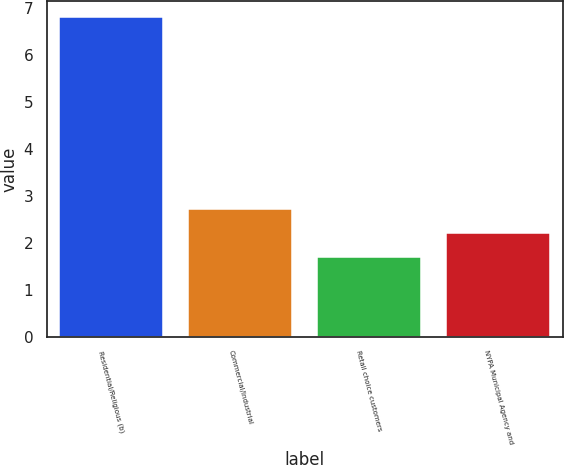Convert chart. <chart><loc_0><loc_0><loc_500><loc_500><bar_chart><fcel>Residential/Religious (b)<fcel>Commercial/Industrial<fcel>Retail choice customers<fcel>NYPA Municipal Agency and<nl><fcel>6.8<fcel>2.72<fcel>1.7<fcel>2.21<nl></chart> 